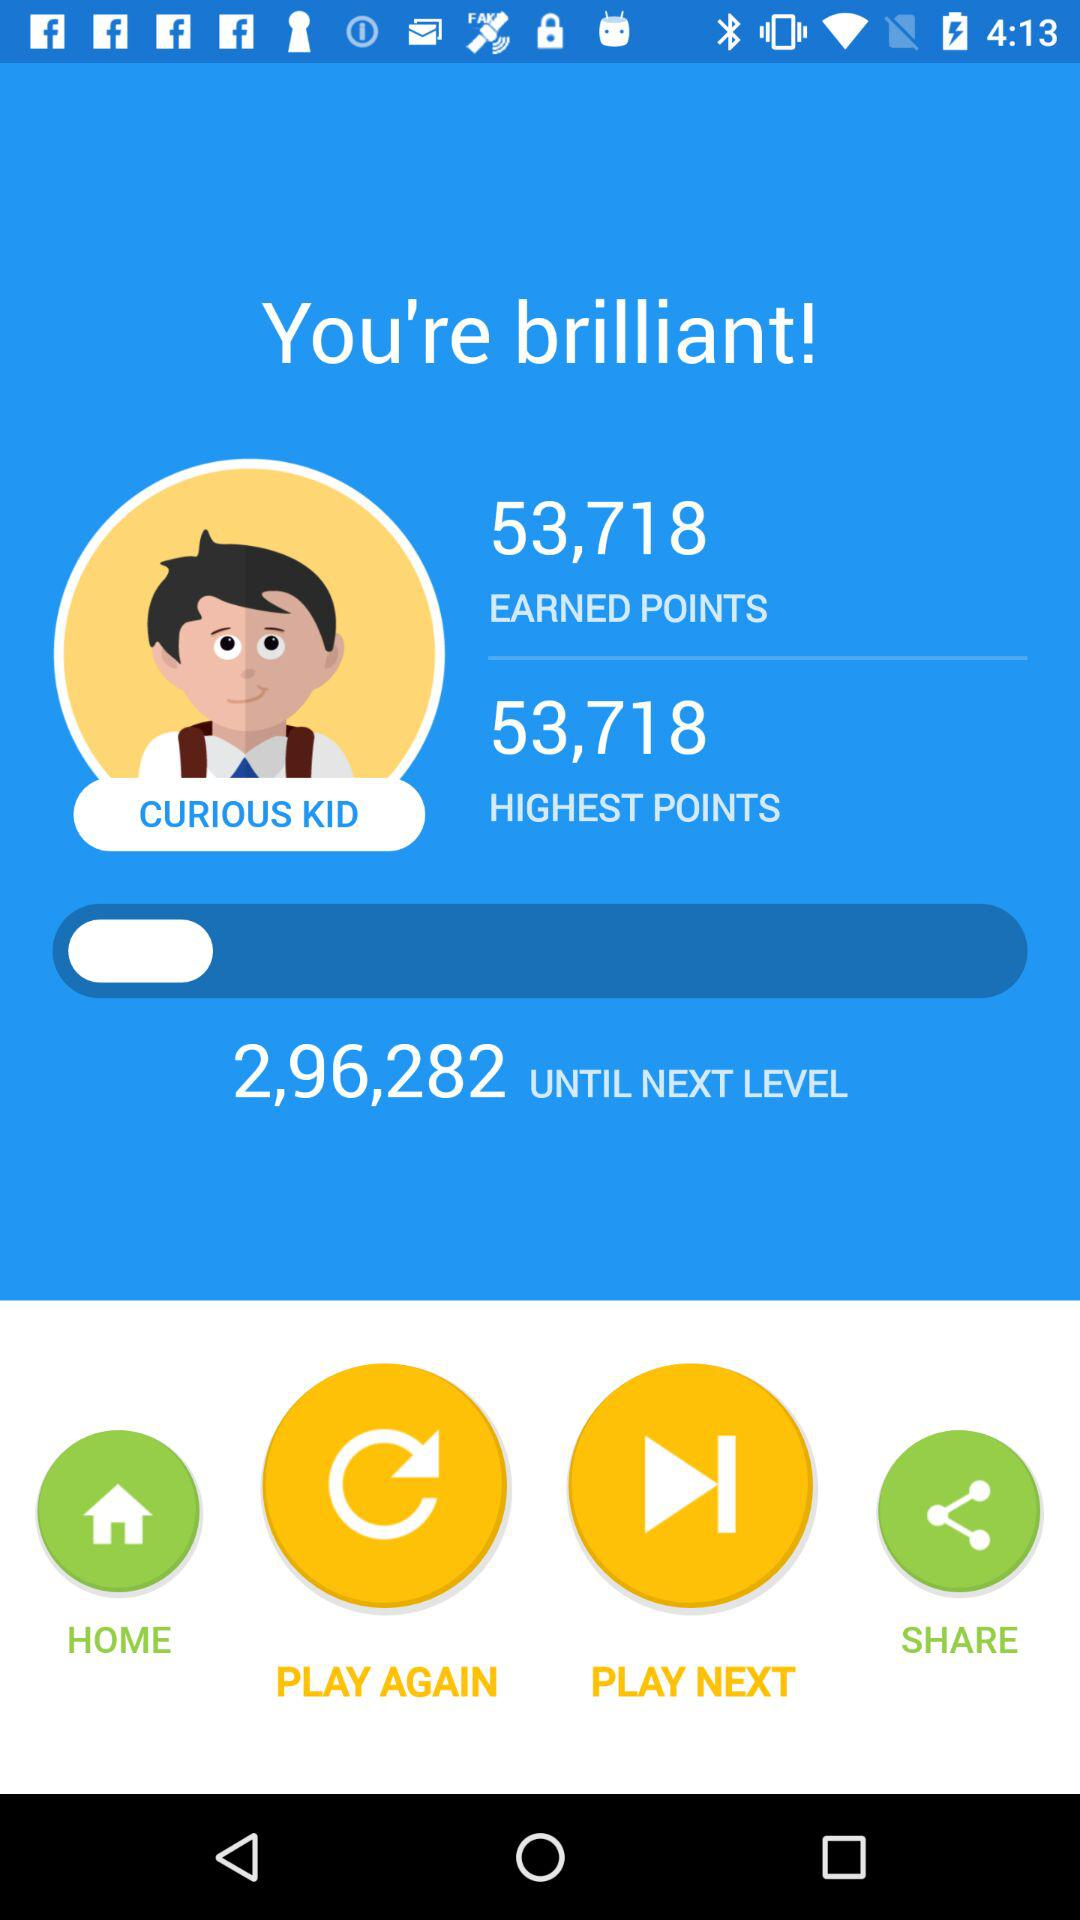What is the highest number of points? The highest number of points is 53,718. 